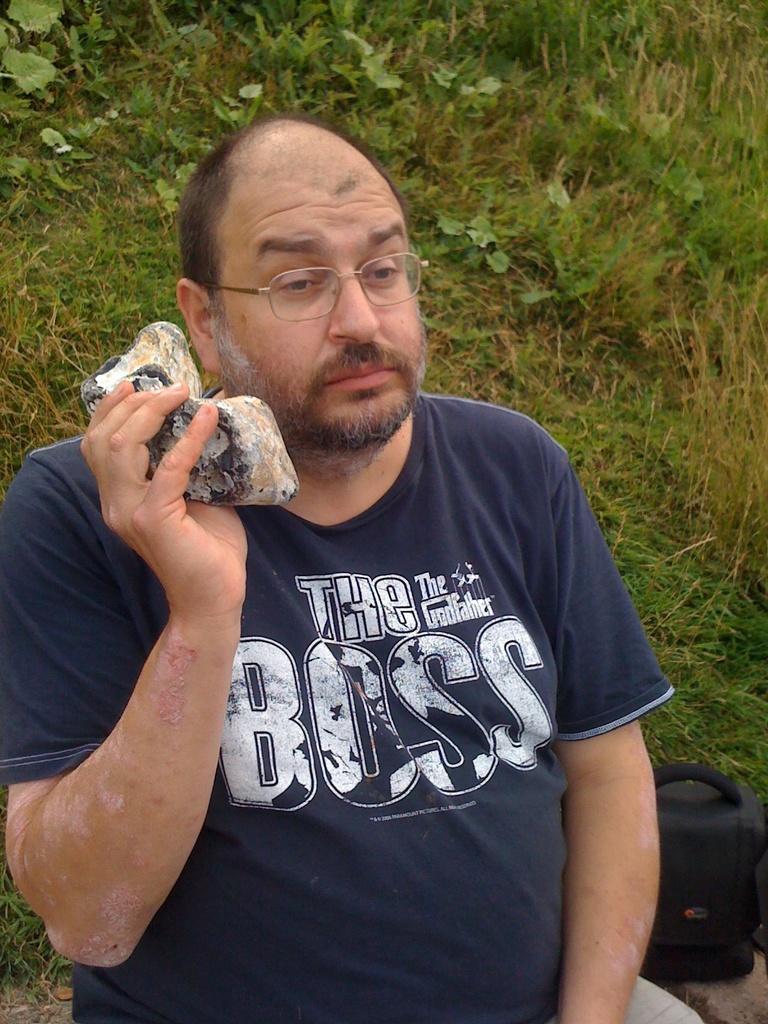How would you summarize this image in a sentence or two? In this image there is a man holding some object. There is grass in the background. On the right bottom there is a bag. 